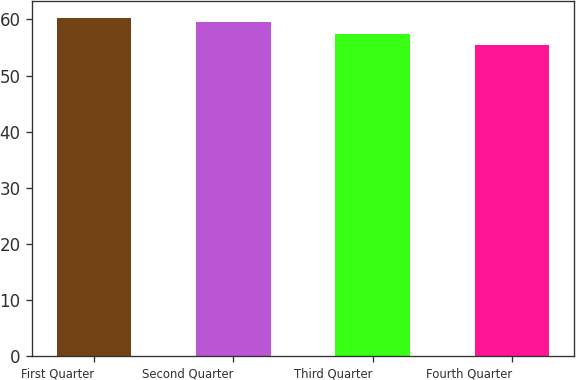Convert chart to OTSL. <chart><loc_0><loc_0><loc_500><loc_500><bar_chart><fcel>First Quarter<fcel>Second Quarter<fcel>Third Quarter<fcel>Fourth Quarter<nl><fcel>60.2<fcel>59.54<fcel>57.45<fcel>55.49<nl></chart> 